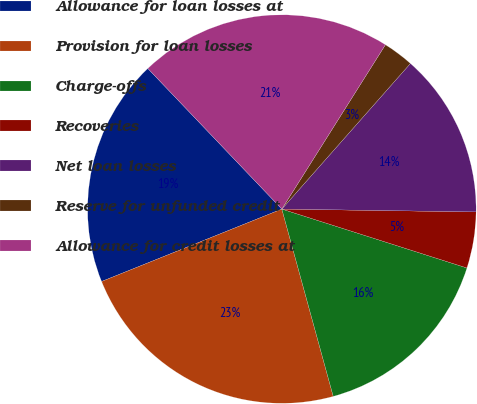Convert chart to OTSL. <chart><loc_0><loc_0><loc_500><loc_500><pie_chart><fcel>Allowance for loan losses at<fcel>Provision for loan losses<fcel>Charge-offs<fcel>Recoveries<fcel>Net loan losses<fcel>Reserve for unfunded credit<fcel>Allowance for credit losses at<nl><fcel>18.96%<fcel>23.18%<fcel>15.83%<fcel>4.67%<fcel>13.72%<fcel>2.56%<fcel>21.07%<nl></chart> 